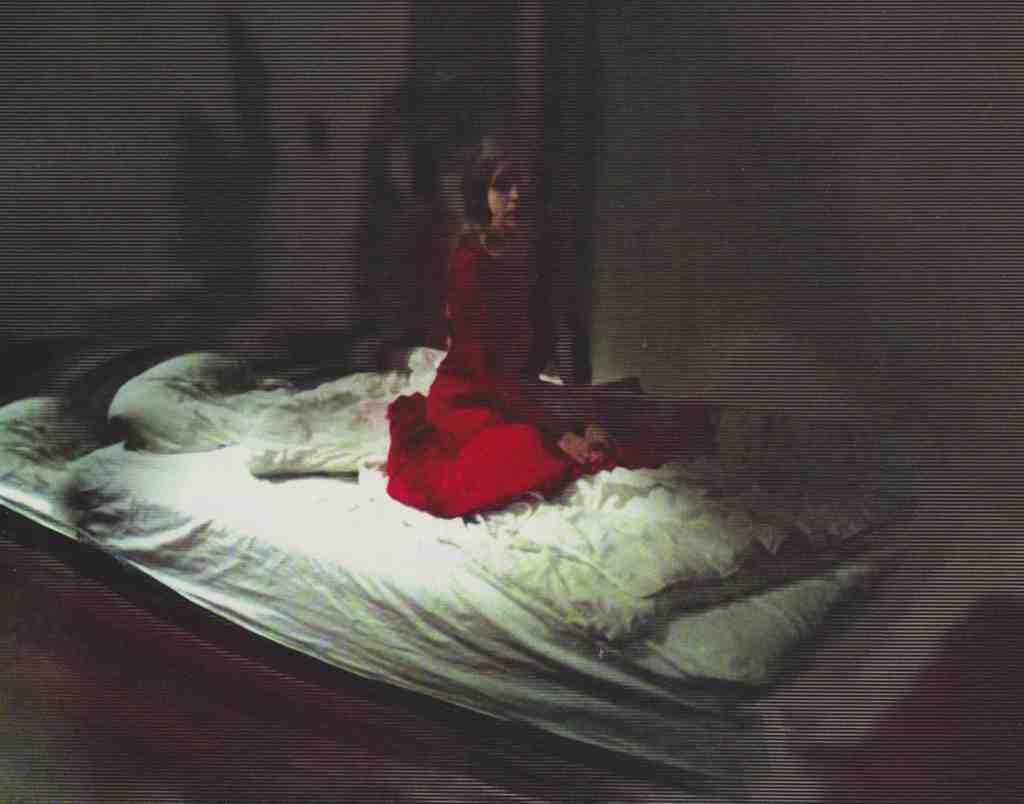Could you give a brief overview of what you see in this image? A woman is sitting on the bed she wear red color dress. 